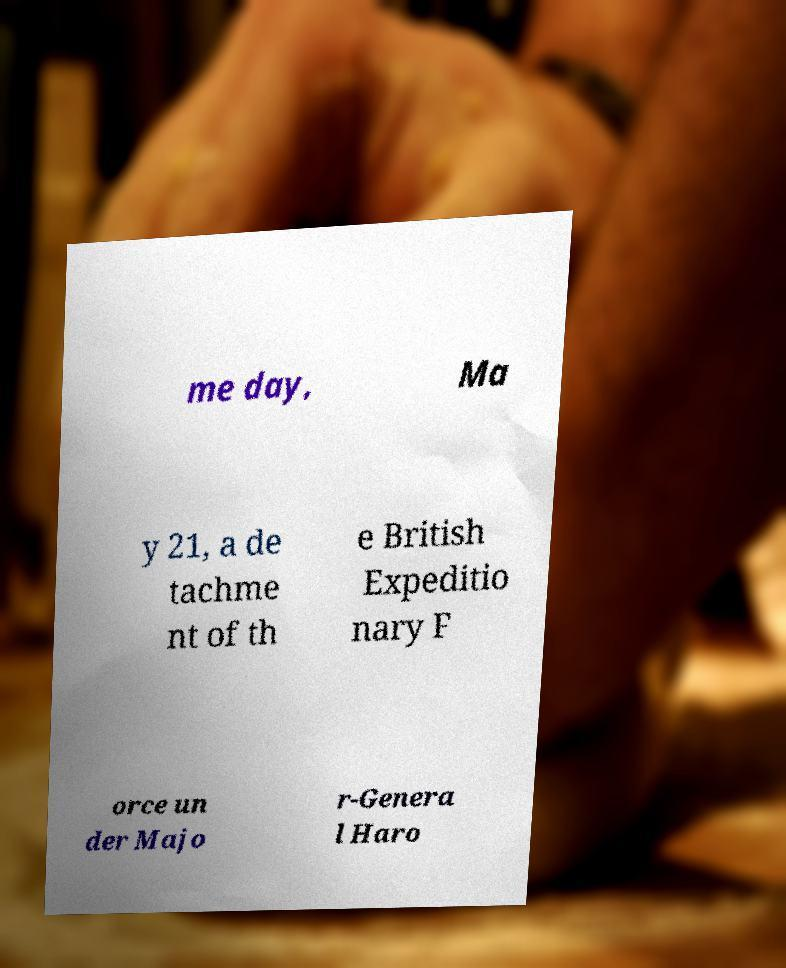Could you extract and type out the text from this image? me day, Ma y 21, a de tachme nt of th e British Expeditio nary F orce un der Majo r-Genera l Haro 